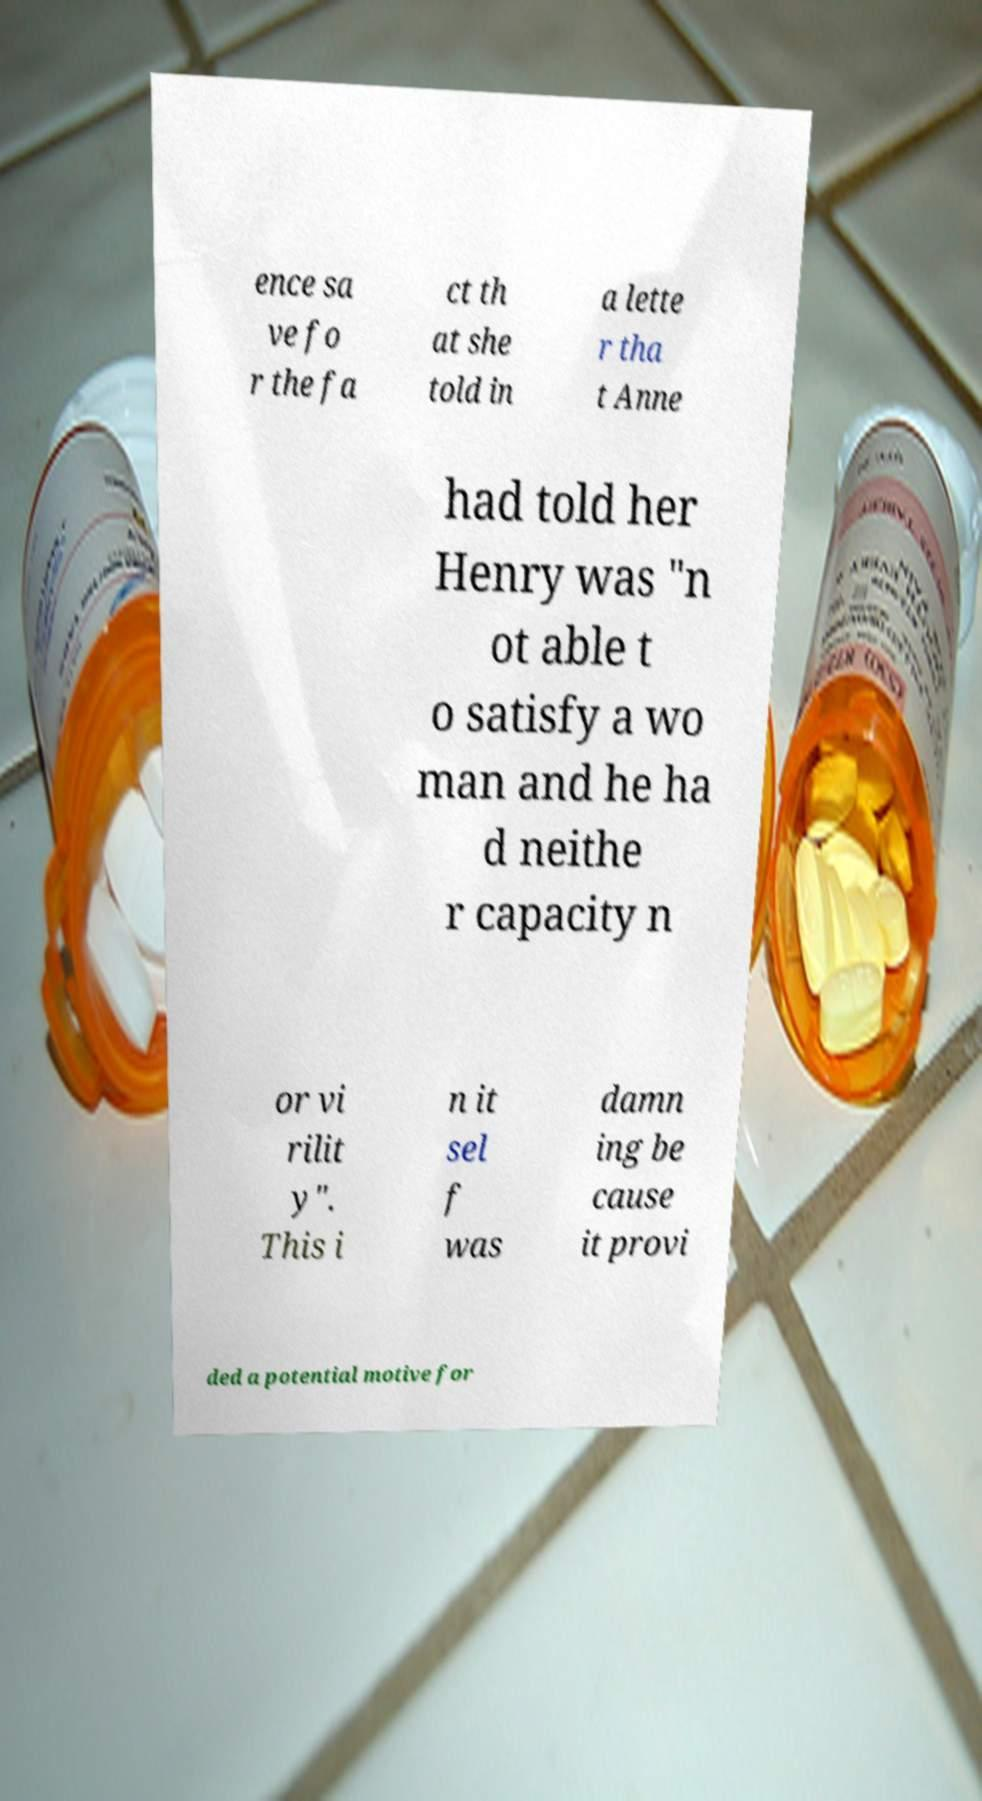Can you read and provide the text displayed in the image?This photo seems to have some interesting text. Can you extract and type it out for me? ence sa ve fo r the fa ct th at she told in a lette r tha t Anne had told her Henry was "n ot able t o satisfy a wo man and he ha d neithe r capacity n or vi rilit y". This i n it sel f was damn ing be cause it provi ded a potential motive for 